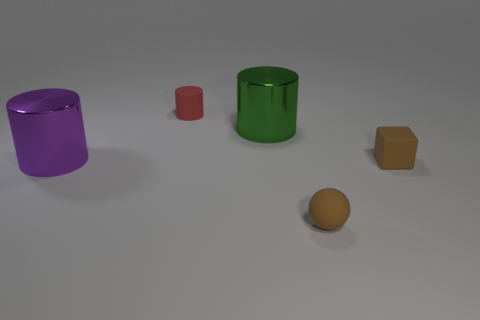Add 3 large green shiny cylinders. How many objects exist? 8 Subtract all balls. How many objects are left? 4 Add 5 big cyan shiny cylinders. How many big cyan shiny cylinders exist? 5 Subtract 0 green spheres. How many objects are left? 5 Subtract all tiny brown cubes. Subtract all big green metal cylinders. How many objects are left? 3 Add 5 tiny red objects. How many tiny red objects are left? 6 